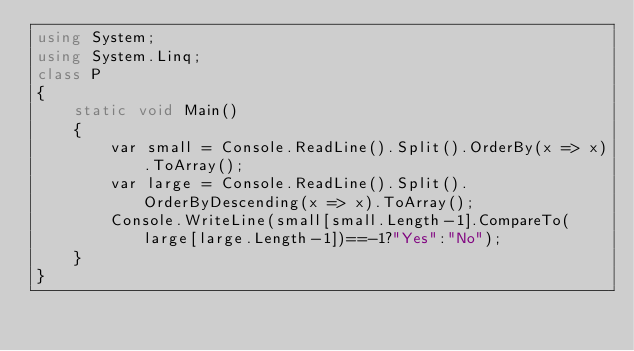Convert code to text. <code><loc_0><loc_0><loc_500><loc_500><_C#_>using System;
using System.Linq;
class P
{
    static void Main()
    {
        var small = Console.ReadLine().Split().OrderBy(x => x).ToArray();
        var large = Console.ReadLine().Split().OrderByDescending(x => x).ToArray();
        Console.WriteLine(small[small.Length-1].CompareTo(large[large.Length-1])==-1?"Yes":"No");
    }
}
</code> 